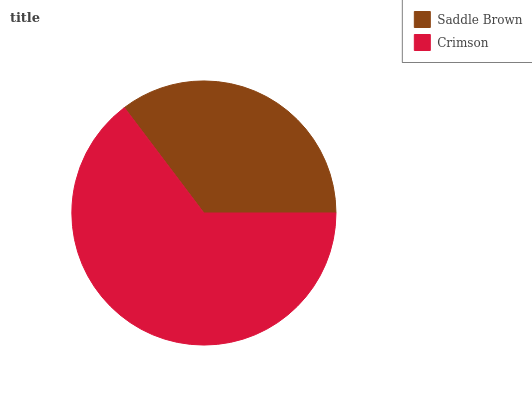Is Saddle Brown the minimum?
Answer yes or no. Yes. Is Crimson the maximum?
Answer yes or no. Yes. Is Crimson the minimum?
Answer yes or no. No. Is Crimson greater than Saddle Brown?
Answer yes or no. Yes. Is Saddle Brown less than Crimson?
Answer yes or no. Yes. Is Saddle Brown greater than Crimson?
Answer yes or no. No. Is Crimson less than Saddle Brown?
Answer yes or no. No. Is Crimson the high median?
Answer yes or no. Yes. Is Saddle Brown the low median?
Answer yes or no. Yes. Is Saddle Brown the high median?
Answer yes or no. No. Is Crimson the low median?
Answer yes or no. No. 